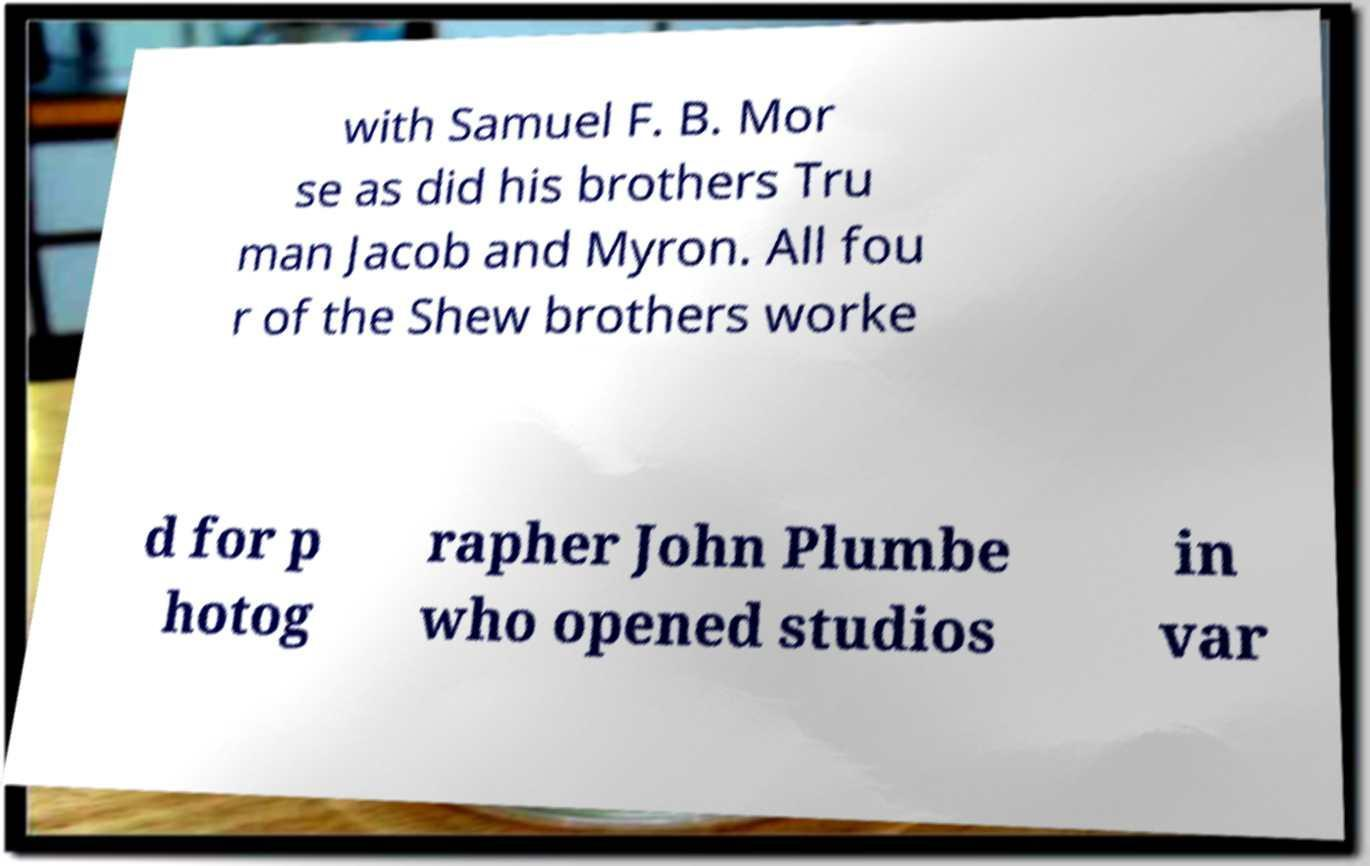Please identify and transcribe the text found in this image. with Samuel F. B. Mor se as did his brothers Tru man Jacob and Myron. All fou r of the Shew brothers worke d for p hotog rapher John Plumbe who opened studios in var 